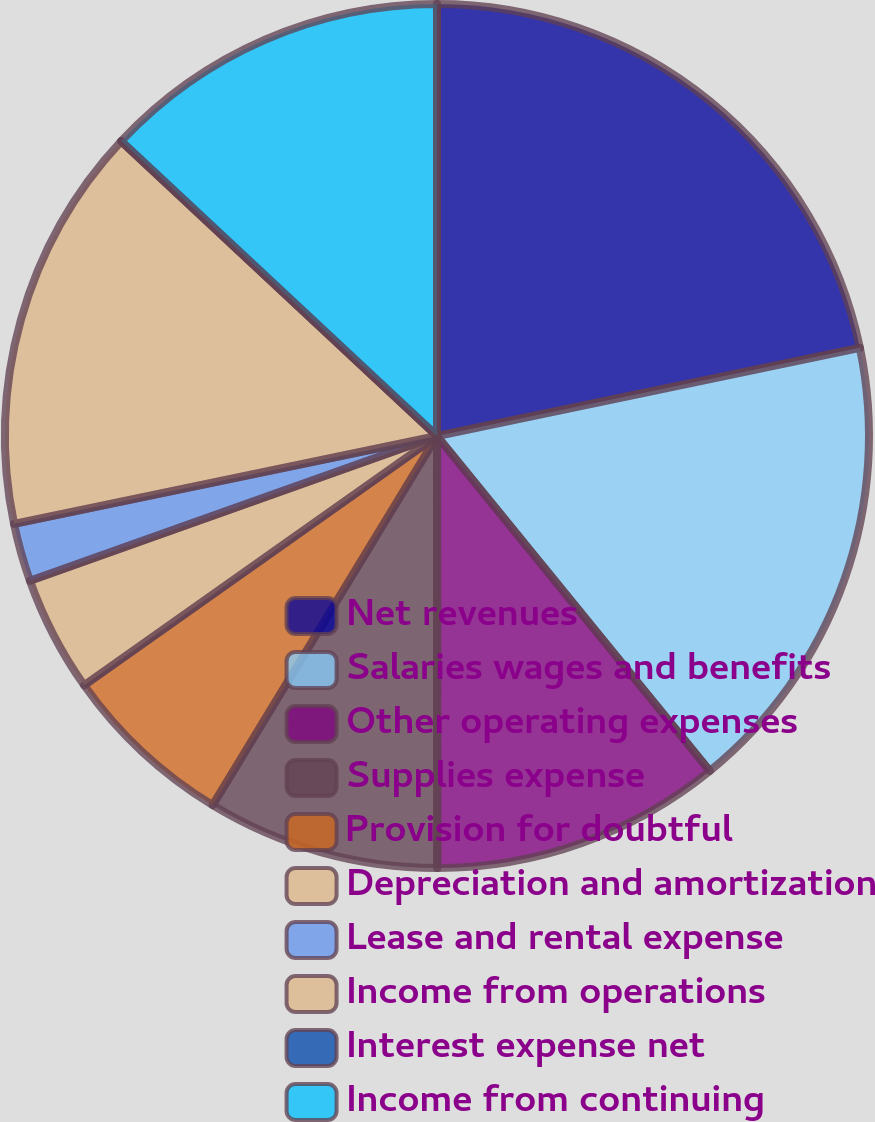Convert chart to OTSL. <chart><loc_0><loc_0><loc_500><loc_500><pie_chart><fcel>Net revenues<fcel>Salaries wages and benefits<fcel>Other operating expenses<fcel>Supplies expense<fcel>Provision for doubtful<fcel>Depreciation and amortization<fcel>Lease and rental expense<fcel>Income from operations<fcel>Interest expense net<fcel>Income from continuing<nl><fcel>21.73%<fcel>17.39%<fcel>10.87%<fcel>8.7%<fcel>6.52%<fcel>4.35%<fcel>2.18%<fcel>15.21%<fcel>0.01%<fcel>13.04%<nl></chart> 